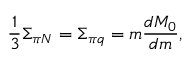Convert formula to latex. <formula><loc_0><loc_0><loc_500><loc_500>{ \frac { 1 } { 3 } } \Sigma _ { \pi N } = \Sigma _ { \pi q } = m { \frac { d M _ { 0 } } { d m } } ,</formula> 